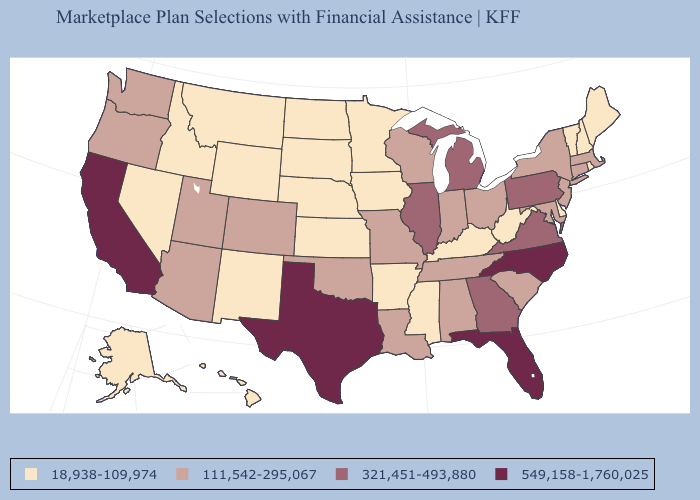Does New Jersey have the same value as Connecticut?
Keep it brief. Yes. Does Colorado have the highest value in the USA?
Answer briefly. No. Is the legend a continuous bar?
Write a very short answer. No. Which states have the lowest value in the USA?
Answer briefly. Alaska, Arkansas, Delaware, Hawaii, Idaho, Iowa, Kansas, Kentucky, Maine, Minnesota, Mississippi, Montana, Nebraska, Nevada, New Hampshire, New Mexico, North Dakota, Rhode Island, South Dakota, Vermont, West Virginia, Wyoming. What is the lowest value in the MidWest?
Quick response, please. 18,938-109,974. What is the value of Massachusetts?
Concise answer only. 111,542-295,067. What is the value of Louisiana?
Answer briefly. 111,542-295,067. Among the states that border North Dakota , which have the lowest value?
Quick response, please. Minnesota, Montana, South Dakota. What is the lowest value in the USA?
Answer briefly. 18,938-109,974. What is the value of Alabama?
Concise answer only. 111,542-295,067. What is the value of Georgia?
Short answer required. 321,451-493,880. Does Illinois have the same value as Kentucky?
Keep it brief. No. Does Massachusetts have the lowest value in the USA?
Concise answer only. No. What is the lowest value in states that border Kentucky?
Write a very short answer. 18,938-109,974. What is the value of North Carolina?
Write a very short answer. 549,158-1,760,025. 